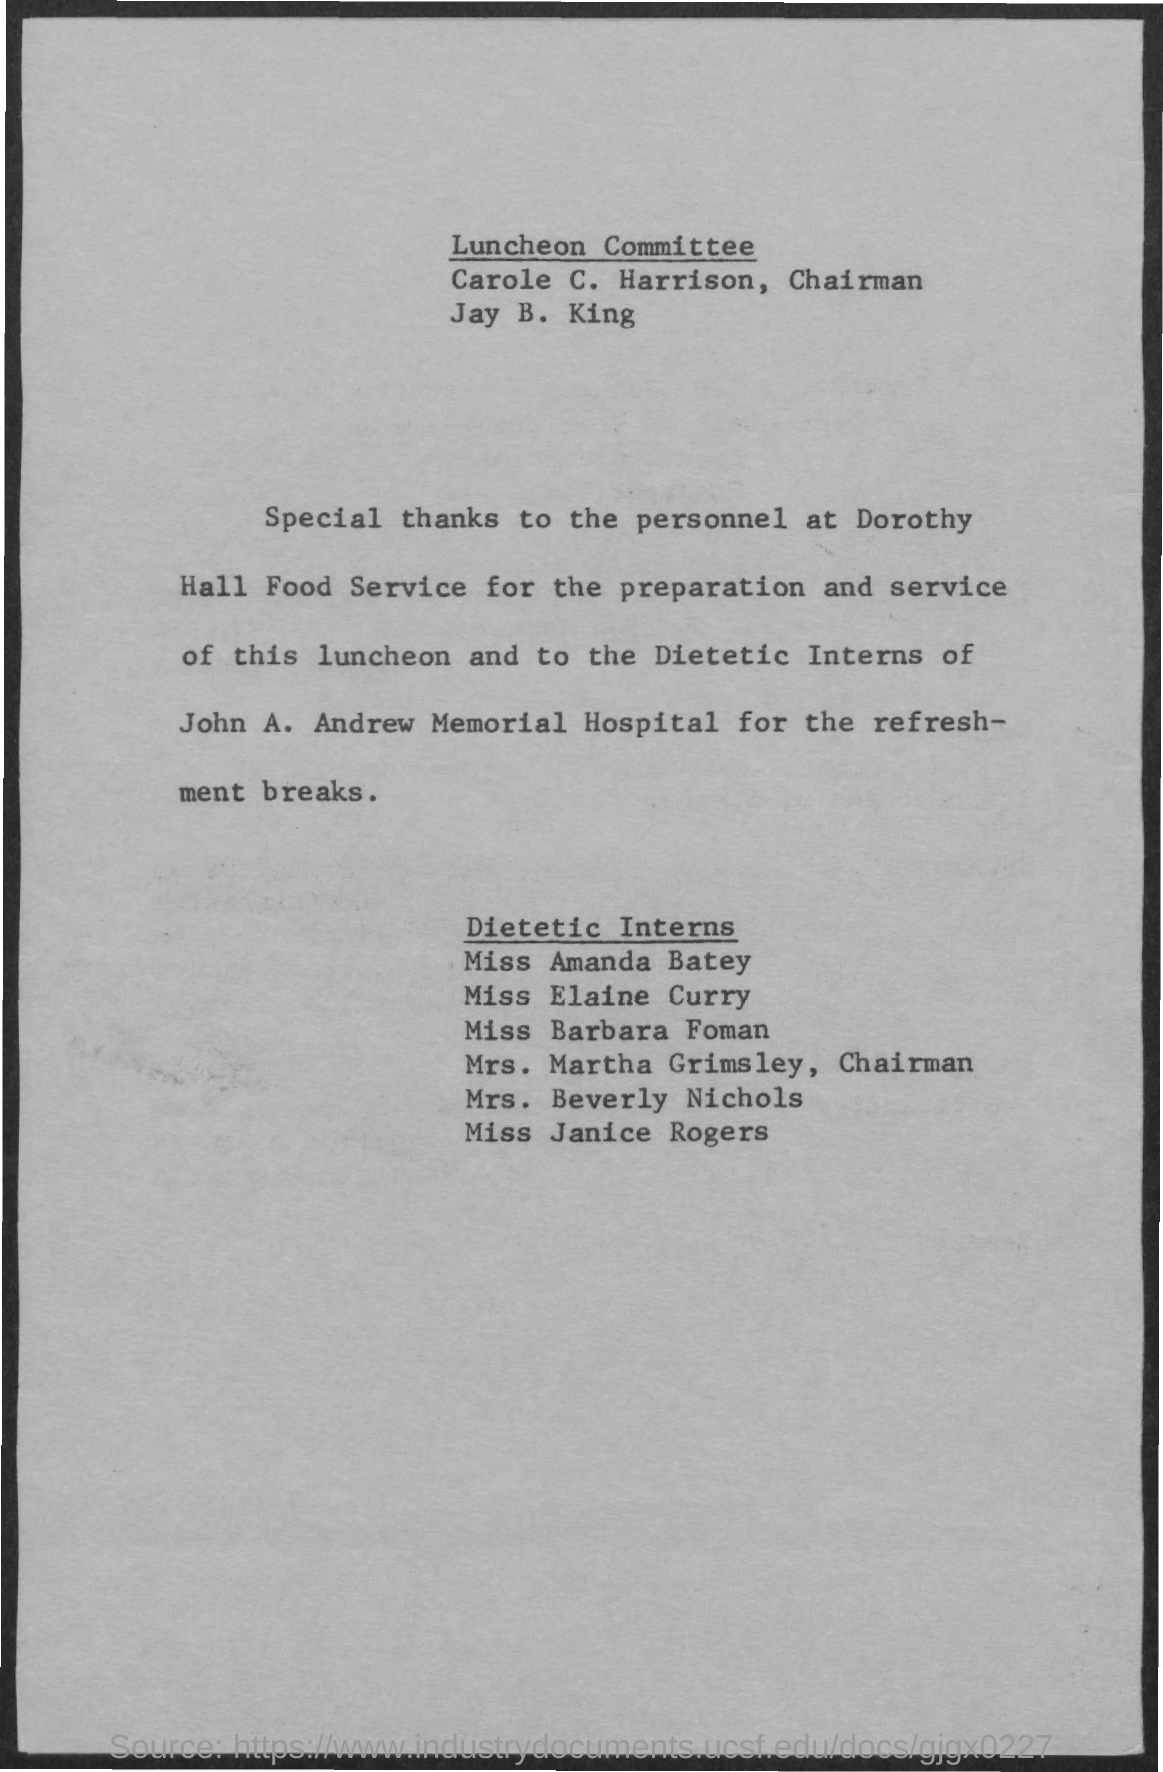Highlight a few significant elements in this photo. The hospital mentioned in the document is John A. Andrew Memorial Hospital. 